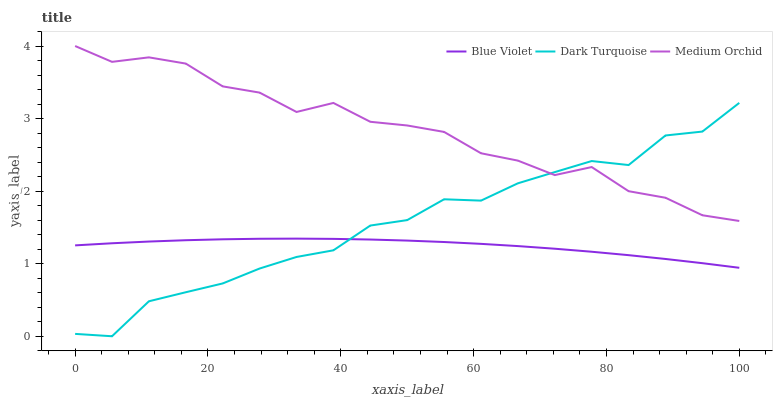Does Blue Violet have the minimum area under the curve?
Answer yes or no. Yes. Does Medium Orchid have the maximum area under the curve?
Answer yes or no. Yes. Does Medium Orchid have the minimum area under the curve?
Answer yes or no. No. Does Blue Violet have the maximum area under the curve?
Answer yes or no. No. Is Blue Violet the smoothest?
Answer yes or no. Yes. Is Medium Orchid the roughest?
Answer yes or no. Yes. Is Medium Orchid the smoothest?
Answer yes or no. No. Is Blue Violet the roughest?
Answer yes or no. No. Does Dark Turquoise have the lowest value?
Answer yes or no. Yes. Does Blue Violet have the lowest value?
Answer yes or no. No. Does Medium Orchid have the highest value?
Answer yes or no. Yes. Does Blue Violet have the highest value?
Answer yes or no. No. Is Blue Violet less than Medium Orchid?
Answer yes or no. Yes. Is Medium Orchid greater than Blue Violet?
Answer yes or no. Yes. Does Blue Violet intersect Dark Turquoise?
Answer yes or no. Yes. Is Blue Violet less than Dark Turquoise?
Answer yes or no. No. Is Blue Violet greater than Dark Turquoise?
Answer yes or no. No. Does Blue Violet intersect Medium Orchid?
Answer yes or no. No. 